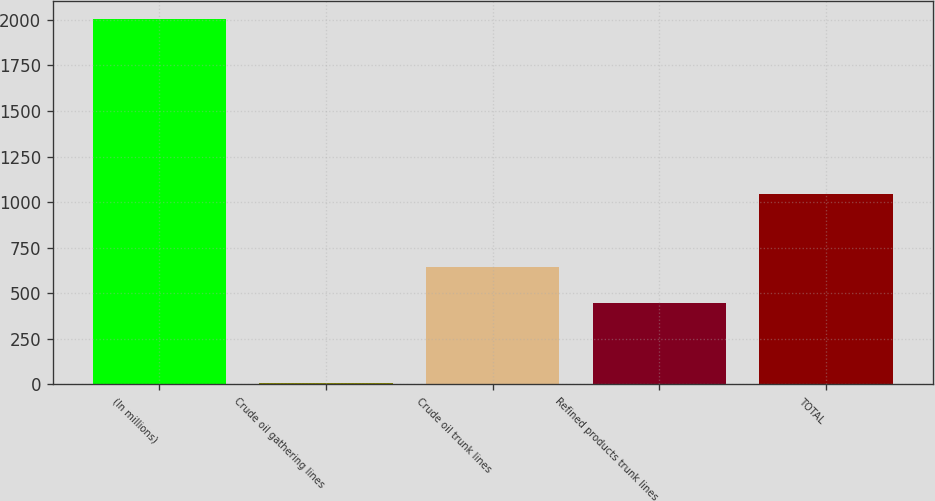<chart> <loc_0><loc_0><loc_500><loc_500><bar_chart><fcel>(In millions)<fcel>Crude oil gathering lines<fcel>Crude oil trunk lines<fcel>Refined products trunk lines<fcel>TOTAL<nl><fcel>2005<fcel>7<fcel>644.8<fcel>445<fcel>1043<nl></chart> 